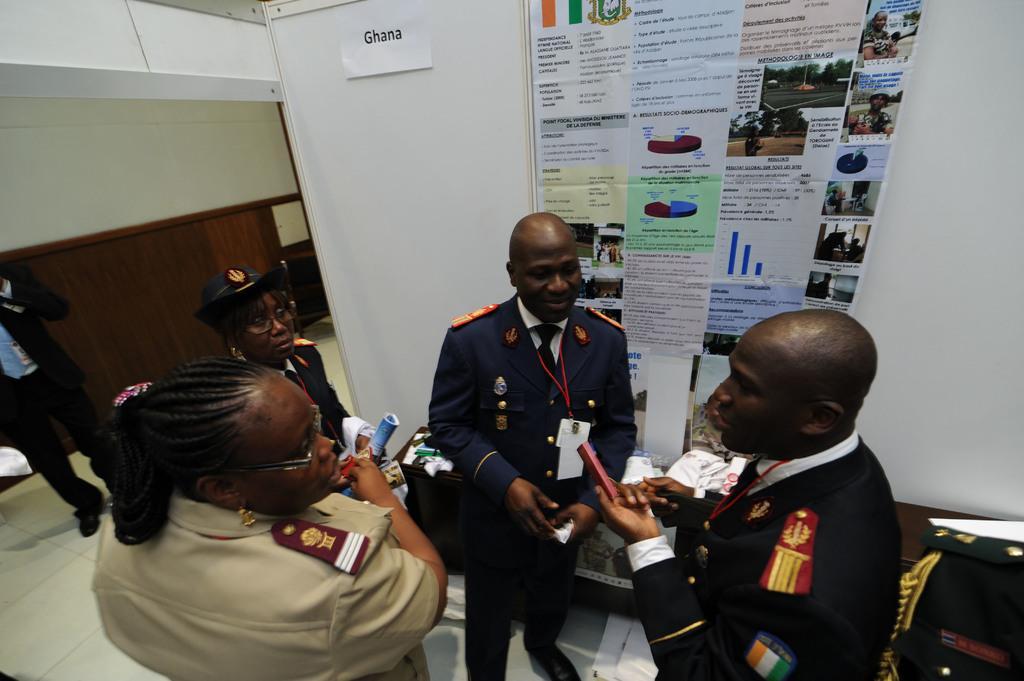Please provide a concise description of this image. In this picture we can see few people on the floor and in the background we can see the wall, posters and few objects. 